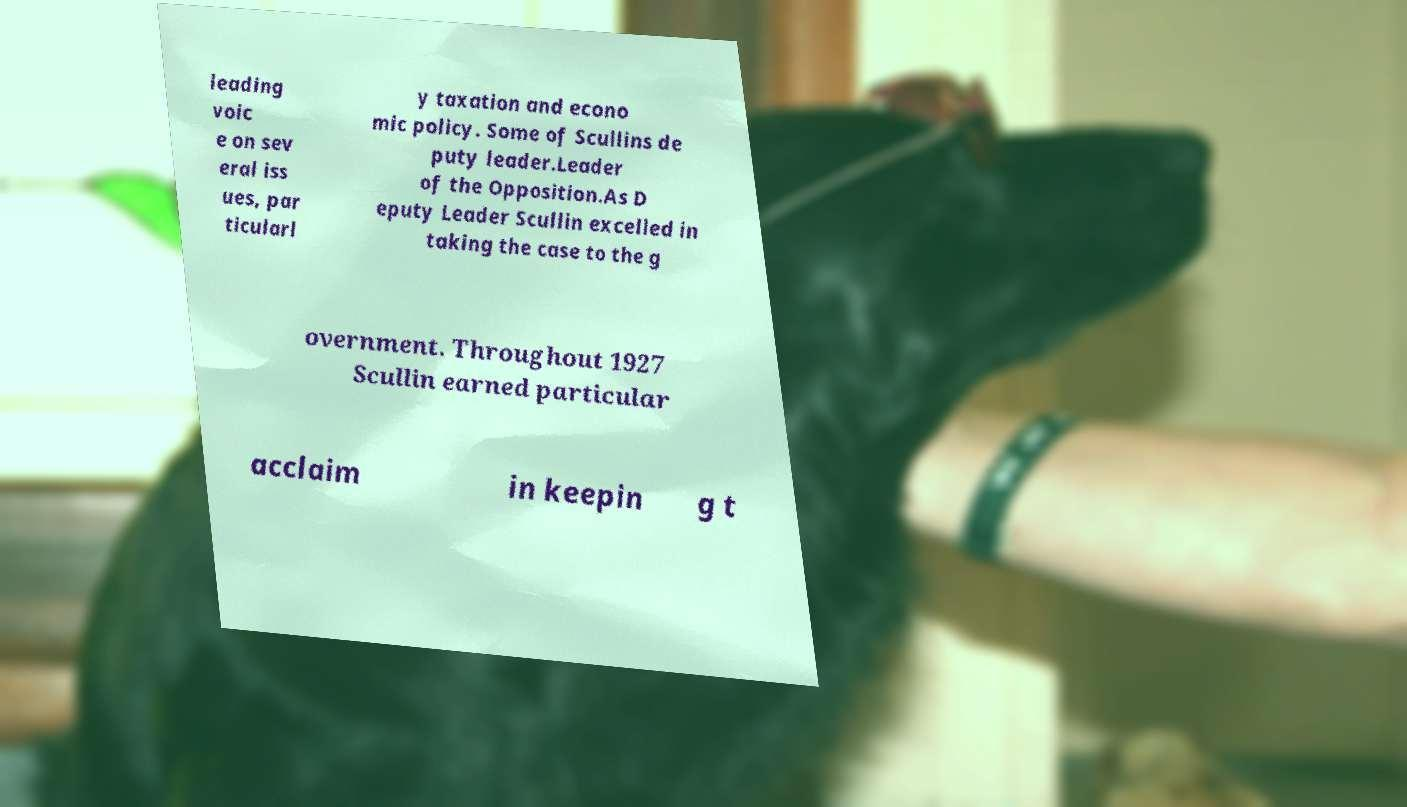Could you extract and type out the text from this image? leading voic e on sev eral iss ues, par ticularl y taxation and econo mic policy. Some of Scullins de puty leader.Leader of the Opposition.As D eputy Leader Scullin excelled in taking the case to the g overnment. Throughout 1927 Scullin earned particular acclaim in keepin g t 